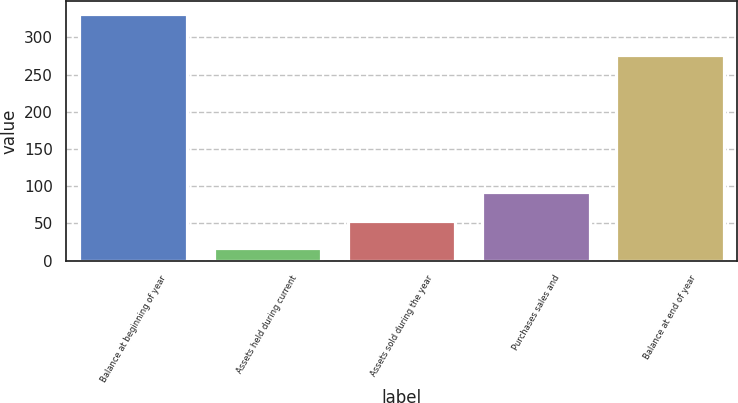Convert chart to OTSL. <chart><loc_0><loc_0><loc_500><loc_500><bar_chart><fcel>Balance at beginning of year<fcel>Assets held during current<fcel>Assets sold during the year<fcel>Purchases sales and<fcel>Balance at end of year<nl><fcel>332<fcel>17<fcel>53<fcel>92<fcel>276<nl></chart> 